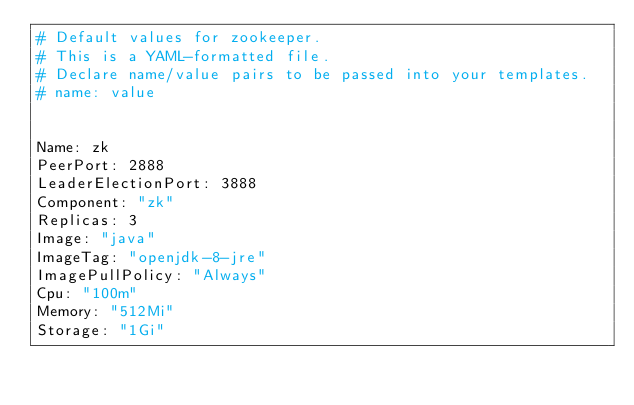Convert code to text. <code><loc_0><loc_0><loc_500><loc_500><_YAML_># Default values for zookeeper.
# This is a YAML-formatted file.
# Declare name/value pairs to be passed into your templates.
# name: value


Name: zk
PeerPort: 2888
LeaderElectionPort: 3888
Component: "zk"
Replicas: 3
Image: "java"
ImageTag: "openjdk-8-jre"
ImagePullPolicy: "Always"
Cpu: "100m"
Memory: "512Mi"
Storage: "1Gi"
</code> 